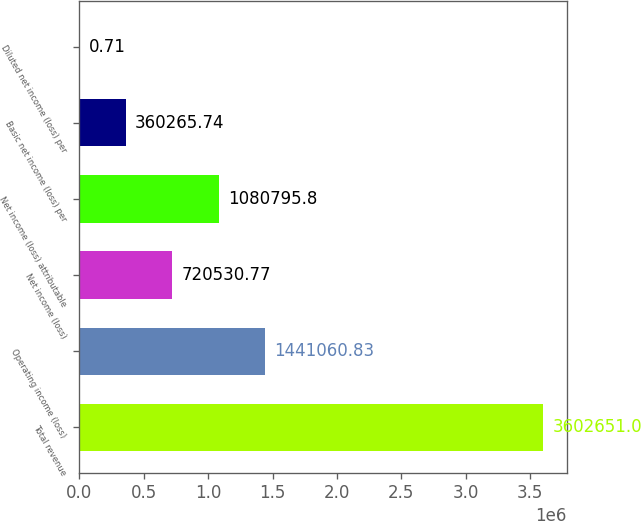<chart> <loc_0><loc_0><loc_500><loc_500><bar_chart><fcel>Total revenue<fcel>Operating income (loss)<fcel>Net income (loss)<fcel>Net income (loss) attributable<fcel>Basic net income (loss) per<fcel>Diluted net income (loss) per<nl><fcel>3.60265e+06<fcel>1.44106e+06<fcel>720531<fcel>1.0808e+06<fcel>360266<fcel>0.71<nl></chart> 